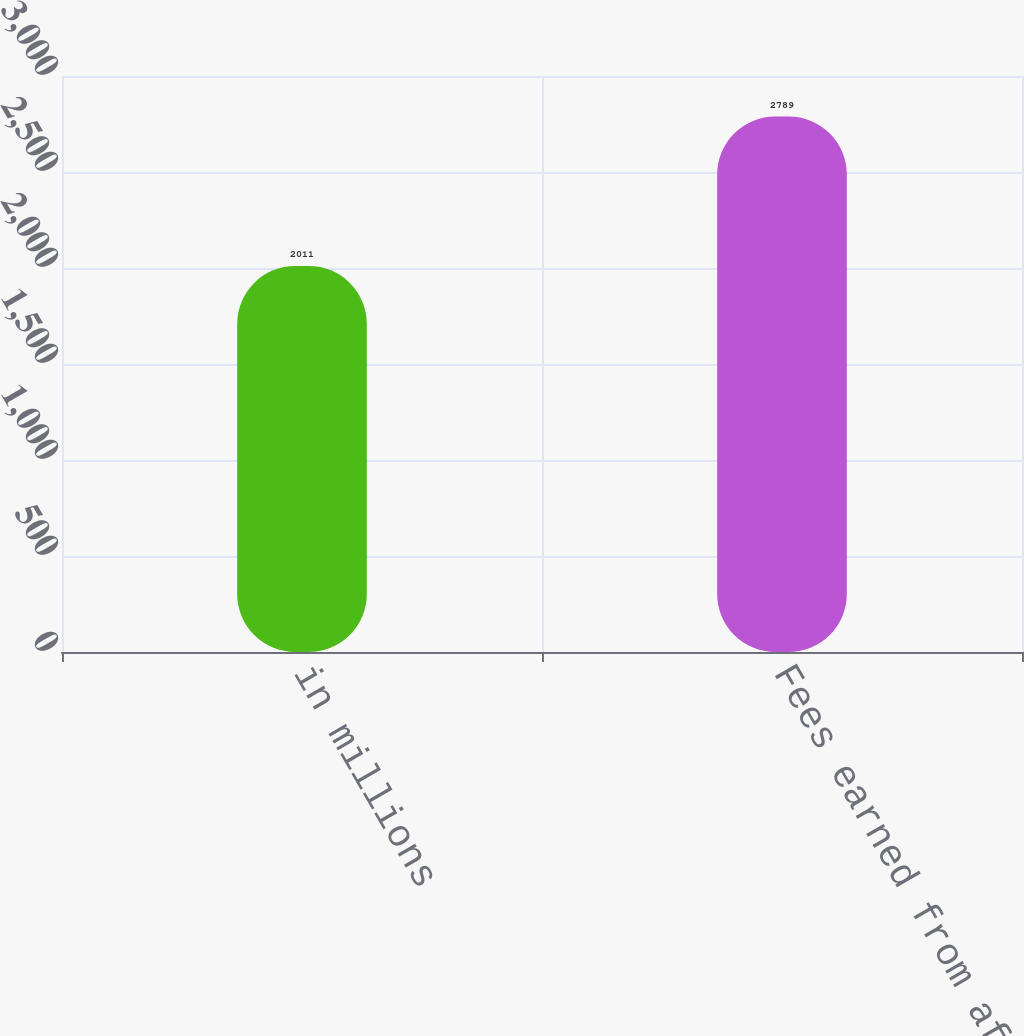Convert chart to OTSL. <chart><loc_0><loc_0><loc_500><loc_500><bar_chart><fcel>in millions<fcel>Fees earned from affiliated<nl><fcel>2011<fcel>2789<nl></chart> 